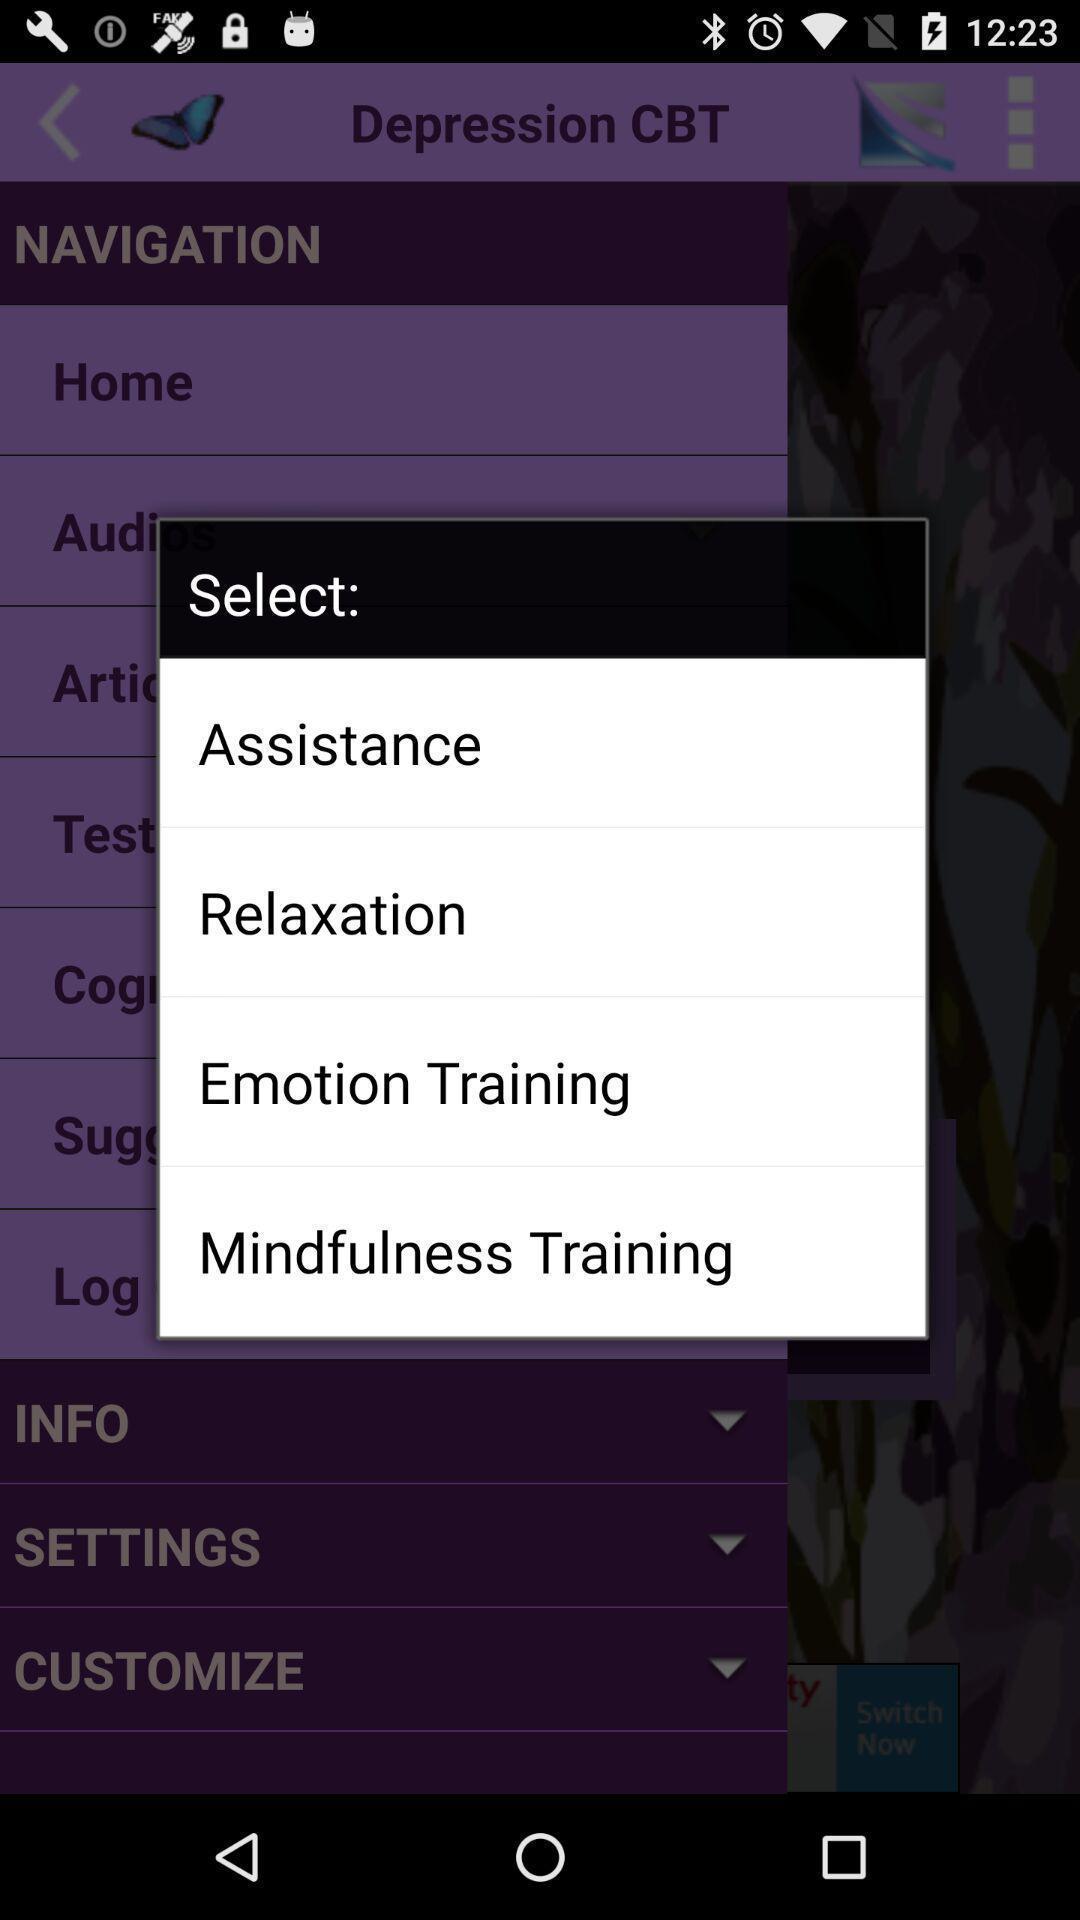Summarize the information in this screenshot. Pop-up displaying different filter options available. 